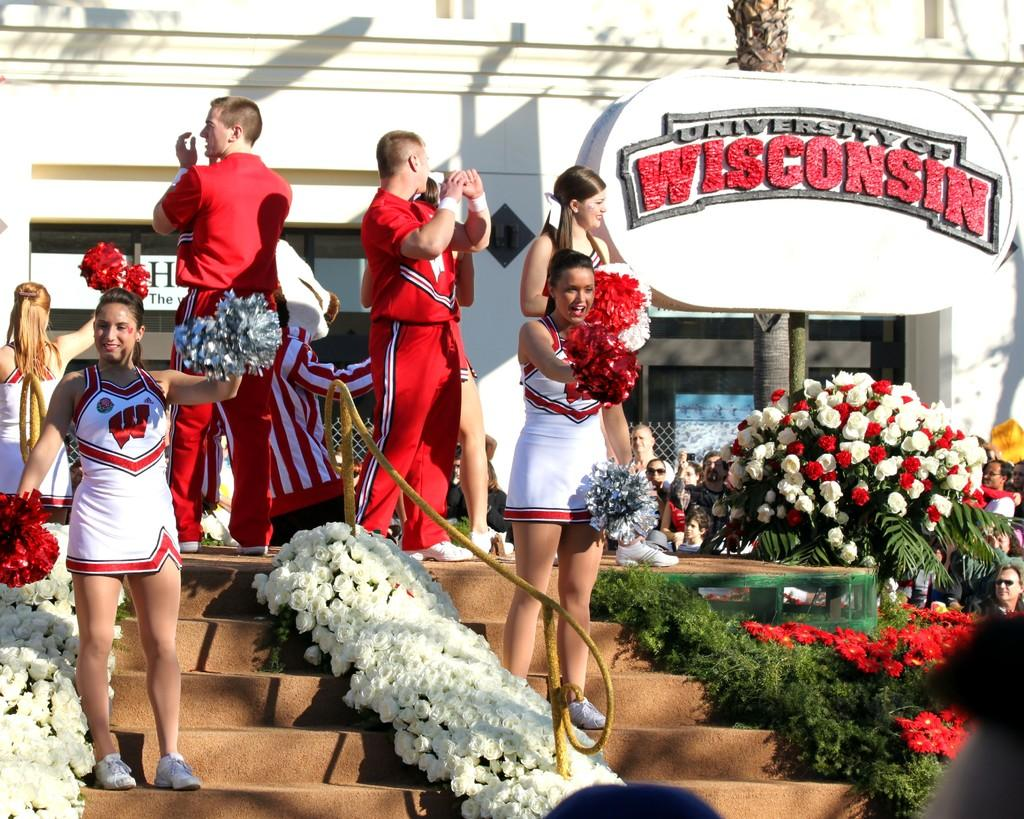<image>
Relay a brief, clear account of the picture shown. Some cheerleaders in front of a sign reading University of Wisconsin. 